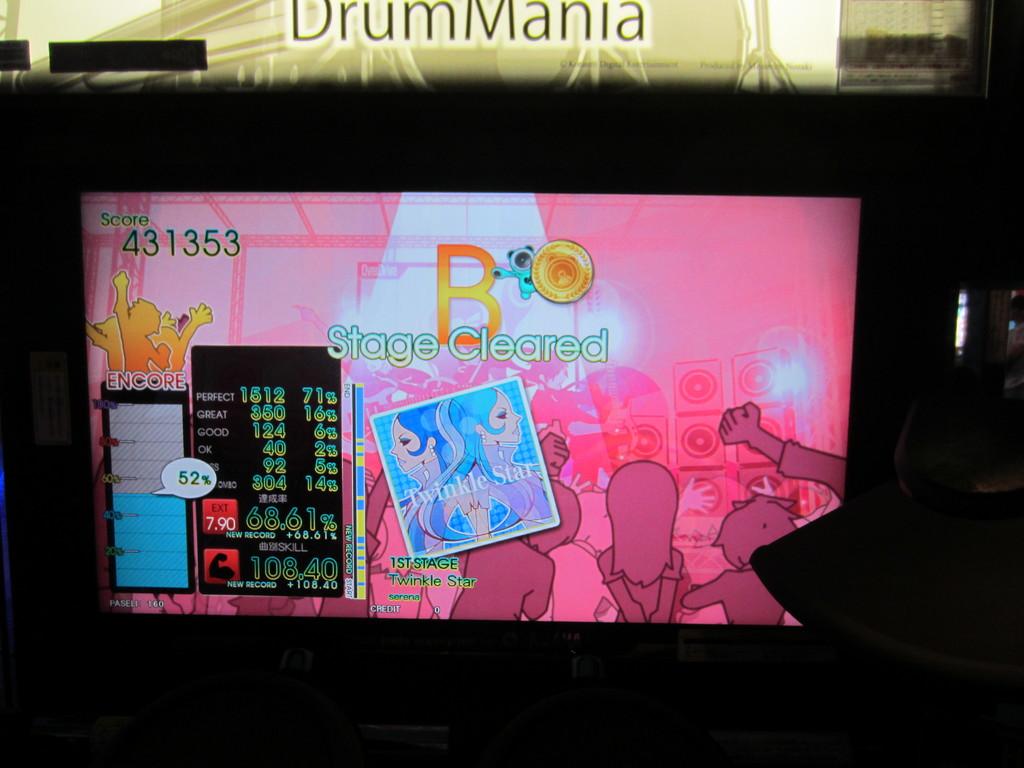What is cleared?
Ensure brevity in your answer.  Stage. How many points did they get?
Provide a succinct answer. 431353. 